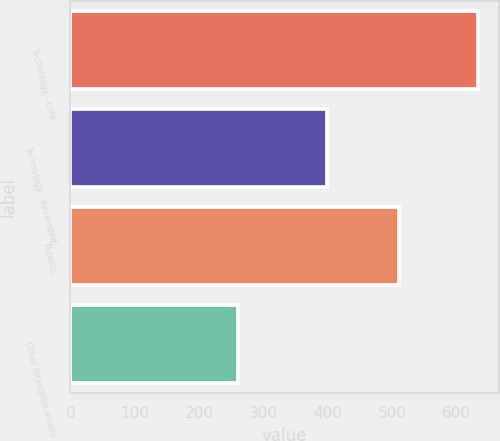Convert chart. <chart><loc_0><loc_0><loc_500><loc_500><bar_chart><fcel>Technology - core<fcel>Technology - developed<fcel>Patents<fcel>Other intangible assets<nl><fcel>634<fcel>398<fcel>511<fcel>260<nl></chart> 